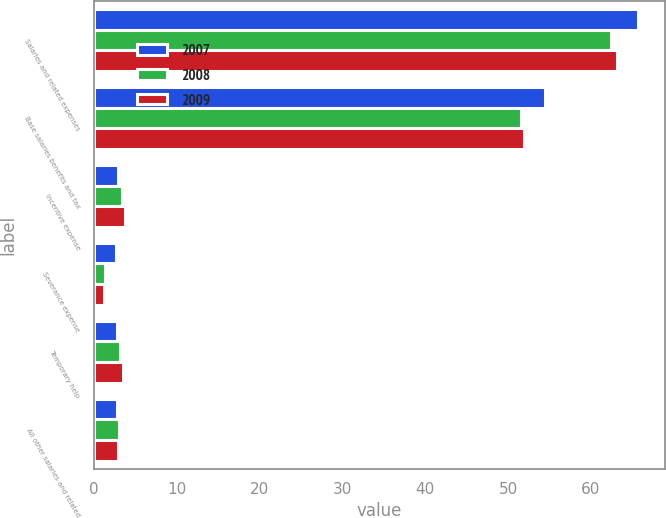<chart> <loc_0><loc_0><loc_500><loc_500><stacked_bar_chart><ecel><fcel>Salaries and related expenses<fcel>Base salaries benefits and tax<fcel>Incentive expense<fcel>Severance expense<fcel>Temporary help<fcel>All other salaries and related<nl><fcel>2007<fcel>65.7<fcel>54.5<fcel>2.9<fcel>2.7<fcel>2.8<fcel>2.8<nl><fcel>2008<fcel>62.4<fcel>51.6<fcel>3.4<fcel>1.3<fcel>3.1<fcel>3<nl><fcel>2009<fcel>63.2<fcel>51.9<fcel>3.7<fcel>1.2<fcel>3.5<fcel>2.9<nl></chart> 